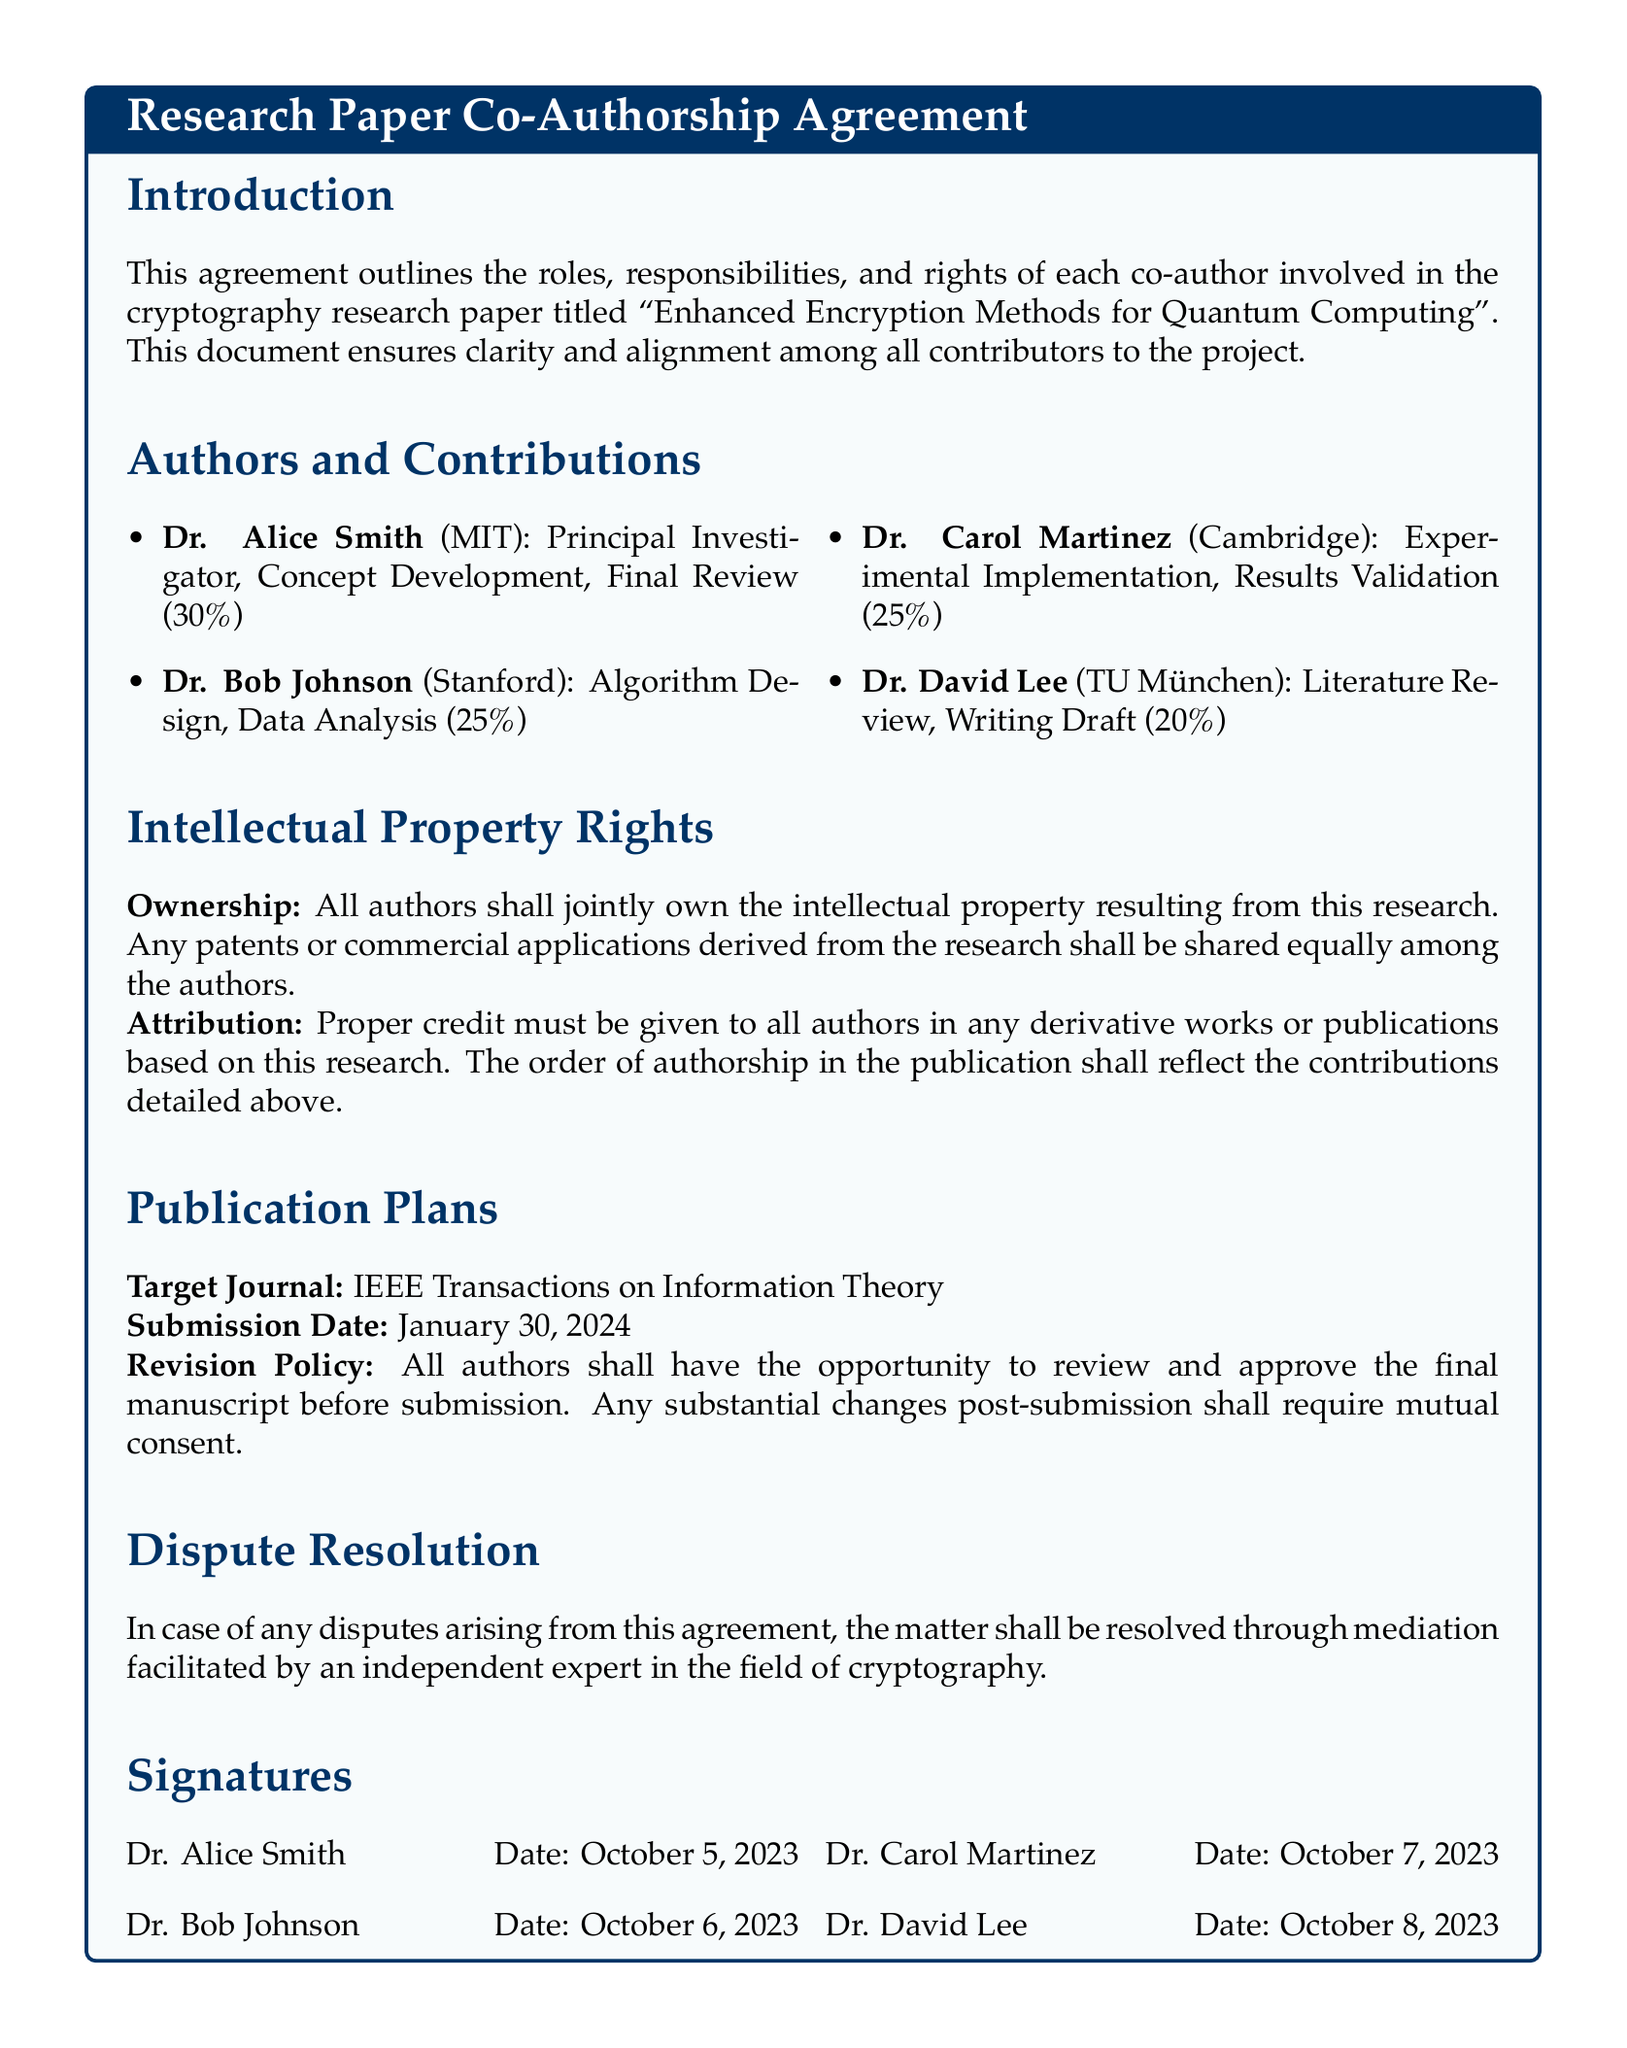What is the title of the research paper? The title of the research paper is mentioned in the introduction section of the document.
Answer: Enhanced Encryption Methods for Quantum Computing Who is the principal investigator of the research paper? The principal investigator is listed under the authors and contributions section.
Answer: Dr. Alice Smith What is Dr. Bob Johnson's contribution percentage? The contribution percentage for Dr. Bob Johnson is specified in the authors and contributions section.
Answer: 25% When is the target submission date for the paper? The target submission date is indicated under the publication plans section.
Answer: January 30, 2024 What is the dispute resolution method mentioned in the agreement? The method for dispute resolution is stated in a specific section of the document.
Answer: Mediation How many authors are involved in the research paper? The number of authors is counted based on the authors and contributions section.
Answer: Four What is the defined ownership arrangement for intellectual property? The ownership arrangement is described in the intellectual property rights section.
Answer: Joint ownership What is Dr. Carol Martinez's primary role? Dr. Carol Martinez's role is delineated in the authors and contributions section.
Answer: Experimental Implementation What is required for any substantial changes post-submission? The requirement for substantial changes is detailed in the publication plans section.
Answer: Mutual consent 